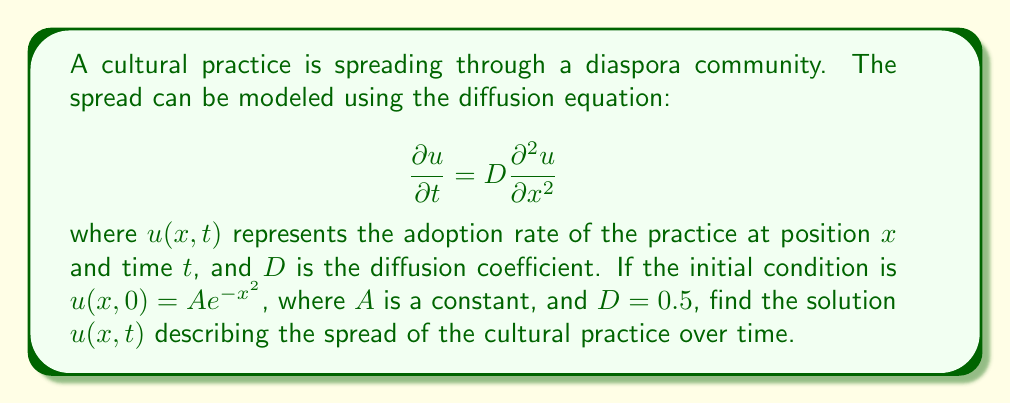Give your solution to this math problem. To solve this diffusion equation with the given initial condition, we'll follow these steps:

1) The general solution for the 1D diffusion equation with initial condition $u(x,0) = f(x)$ is:

   $$u(x,t) = \frac{1}{\sqrt{4\pi Dt}} \int_{-\infty}^{\infty} f(\xi) e^{-\frac{(x-\xi)^2}{4Dt}} d\xi$$

2) In our case, $f(x) = Ae^{-x^2}$ and $D = 0.5$. Substituting these:

   $$u(x,t) = \frac{A}{\sqrt{2\pi t}} \int_{-\infty}^{\infty} e^{-\xi^2} e^{-\frac{(x-\xi)^2}{2t}} d\xi$$

3) To solve this integral, we'll complete the square in the exponent:

   $$-\xi^2 - \frac{(x-\xi)^2}{2t} = -\frac{2t\xi^2 + x^2 - 2x\xi + \xi^2}{2t} = -\frac{(2t+1)\xi^2 - 2x\xi + x^2}{2t}$$

   $$= -\frac{2t+1}{2t}\left(\xi^2 - \frac{2x\xi}{2t+1} + \frac{x^2}{(2t+1)}\right) + \frac{x^2}{2t+1} = -\frac{2t+1}{2t}\left(\xi - \frac{x}{2t+1}\right)^2 + \frac{x^2}{2t+1}$$

4) Substituting this back into the integral:

   $$u(x,t) = \frac{A}{\sqrt{2\pi t}} e^{-\frac{x^2}{2t+1}} \int_{-\infty}^{\infty} e^{-\frac{2t+1}{2t}\left(\xi - \frac{x}{2t+1}\right)^2} d\xi$$

5) This integral evaluates to $\sqrt{\frac{2\pi t}{2t+1}}$, so our solution becomes:

   $$u(x,t) = \frac{A}{\sqrt{1+\frac{1}{2t}}} e^{-\frac{x^2}{2t+1}}$$

This is the solution describing the spread of the cultural practice over time and space.
Answer: $$u(x,t) = \frac{A}{\sqrt{1+\frac{1}{2t}}} e^{-\frac{x^2}{2t+1}}$$ 